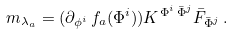<formula> <loc_0><loc_0><loc_500><loc_500>m _ { \lambda _ { a } } = ( \partial _ { \phi ^ { i } } \, f _ { a } ( \Phi ^ { i } ) ) K ^ { \Phi ^ { i } \, { \bar { \Phi } ^ { j } } } { \bar { F } _ { \bar { \Phi } ^ { j } } } \, .</formula> 